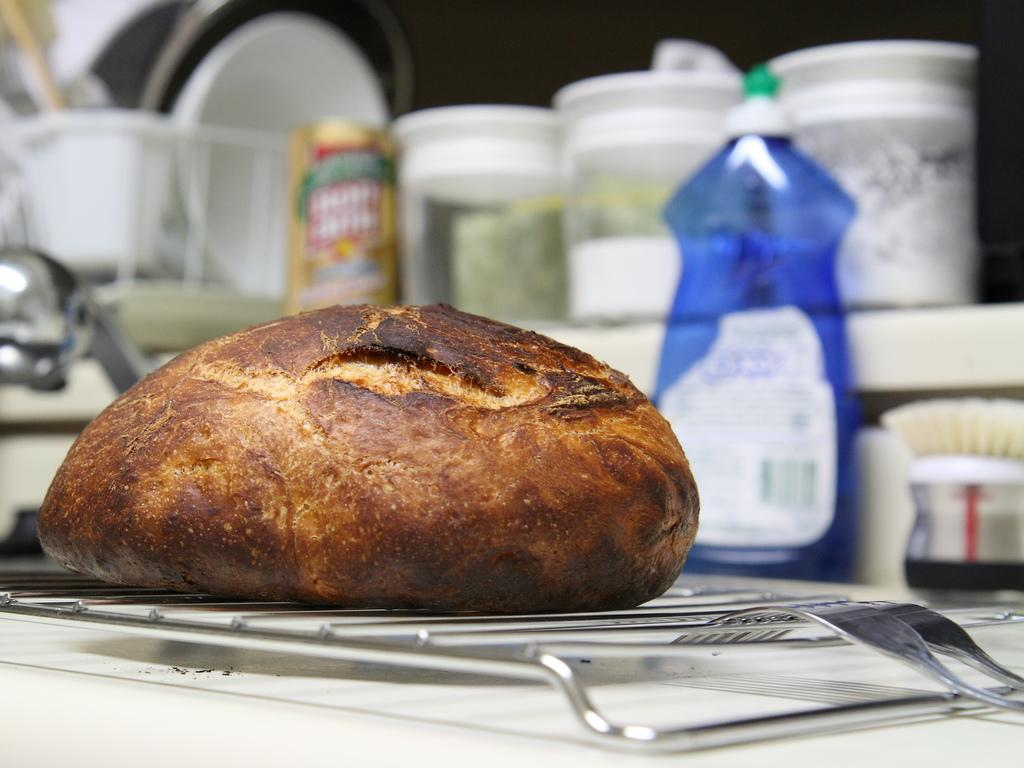What type of food item is on the table in the image? There is a bread on the table. What utensils are present on the table? There are forks on the table. Can you describe any other items visible in the background? There are bowls visible in the background. What type of education can be seen in the image? There is no reference to education in the image; it features a bread and forks on a table. What type of jelly is being served with the bread in the image? There is no jelly present in the image; it only shows a bread and forks on a table. 